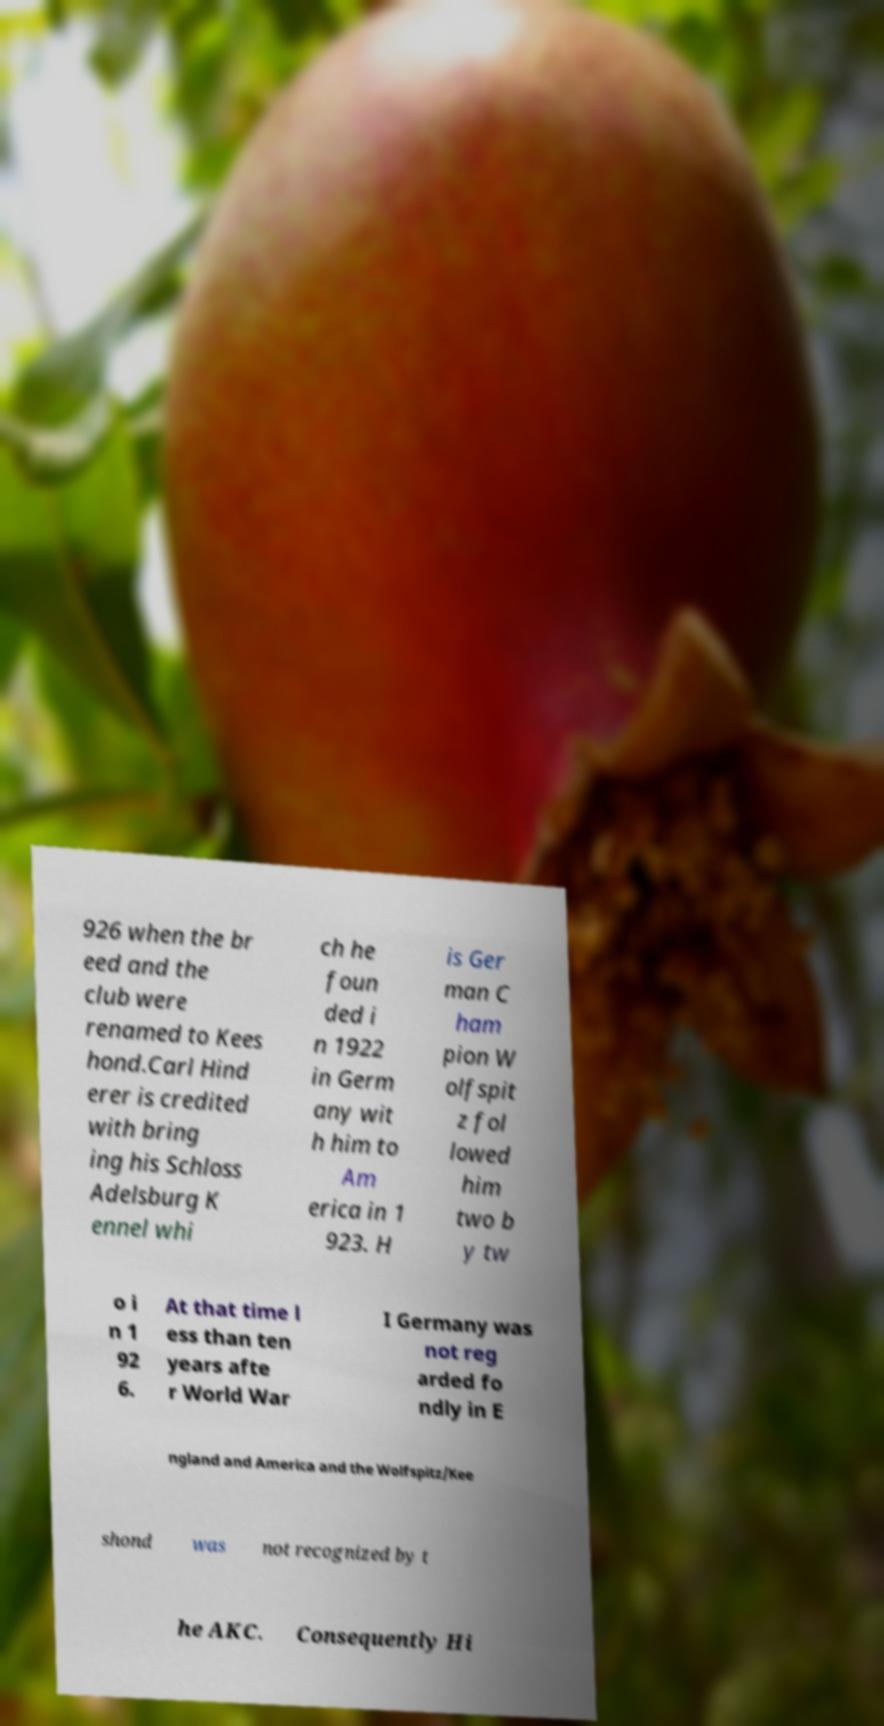Can you accurately transcribe the text from the provided image for me? 926 when the br eed and the club were renamed to Kees hond.Carl Hind erer is credited with bring ing his Schloss Adelsburg K ennel whi ch he foun ded i n 1922 in Germ any wit h him to Am erica in 1 923. H is Ger man C ham pion W olfspit z fol lowed him two b y tw o i n 1 92 6. At that time l ess than ten years afte r World War I Germany was not reg arded fo ndly in E ngland and America and the Wolfspitz/Kee shond was not recognized by t he AKC. Consequently Hi 